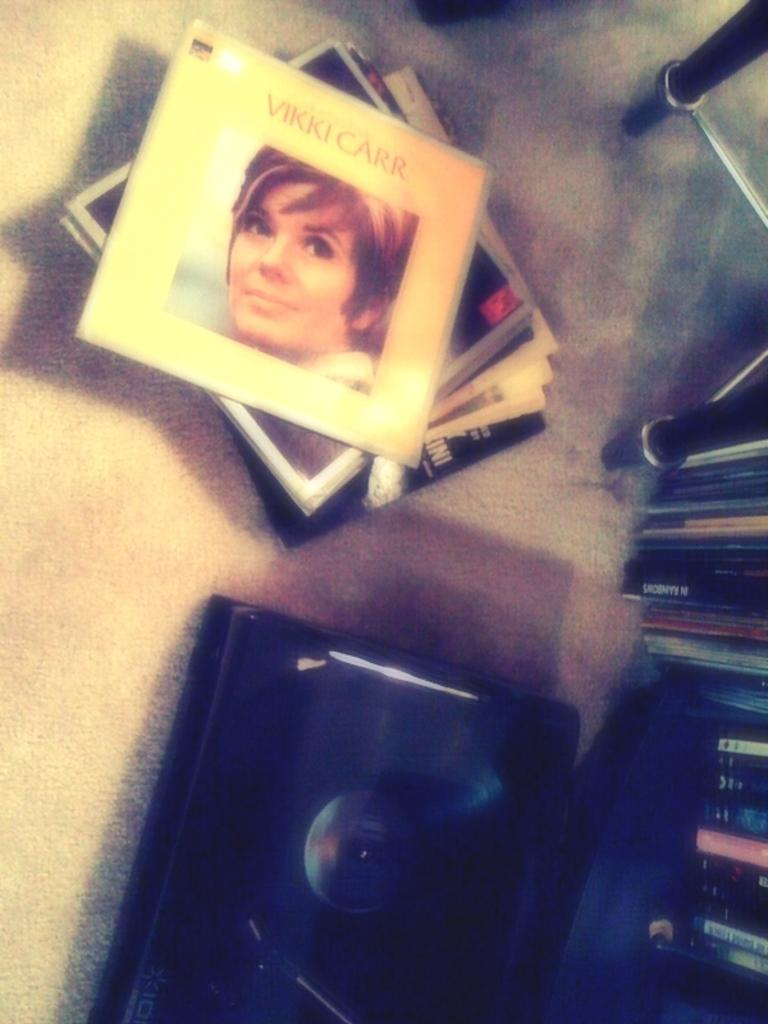What is the main subject of the image? There is a photo of a woman in the image. What else can be seen in the image besides the woman? There is something written in the image, and there are objects on the floor. Can you describe the color of any object in the image? There is a black color thing in the image. How many balloons are floating in the image? There are no balloons present in the image. Is there a road visible in the image? There is no road visible in the image. 